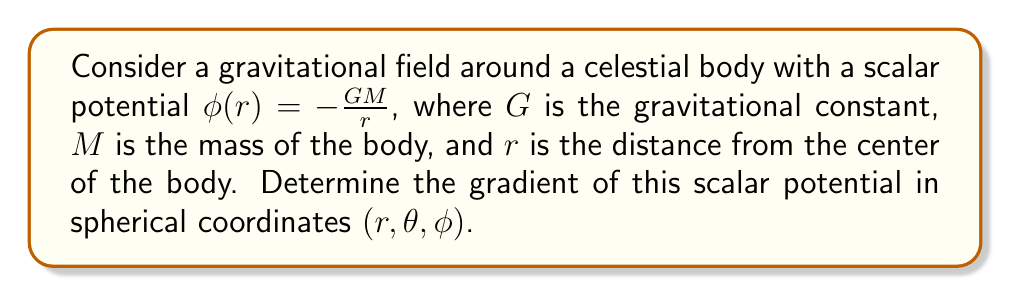Give your solution to this math problem. To solve this problem, we'll follow these steps:

1) The gradient of a scalar potential in spherical coordinates is given by:

   $$\nabla \phi = \frac{\partial \phi}{\partial r}\hat{r} + \frac{1}{r}\frac{\partial \phi}{\partial \theta}\hat{\theta} + \frac{1}{r\sin\theta}\frac{\partial \phi}{\partial \phi}\hat{\phi}$$

2) Our scalar potential $\phi(r) = -\frac{GM}{r}$ is only a function of $r$, so:

   $\frac{\partial \phi}{\partial \theta} = 0$
   $\frac{\partial \phi}{\partial \phi} = 0$

3) We need to calculate $\frac{\partial \phi}{\partial r}$:

   $$\frac{\partial \phi}{\partial r} = \frac{\partial}{\partial r}\left(-\frac{GM}{r}\right) = \frac{GM}{r^2}$$

4) Substituting this into our gradient formula:

   $$\nabla \phi = \frac{GM}{r^2}\hat{r} + 0\hat{\theta} + 0\hat{\phi}$$

5) Simplify:

   $$\nabla \phi = \frac{GM}{r^2}\hat{r}$$

This result shows that the gravitational field (which is the negative of the gradient of the potential) points radially inward and decreases with the square of the distance, consistent with Newton's law of gravitation.
Answer: $\nabla \phi = \frac{GM}{r^2}\hat{r}$ 